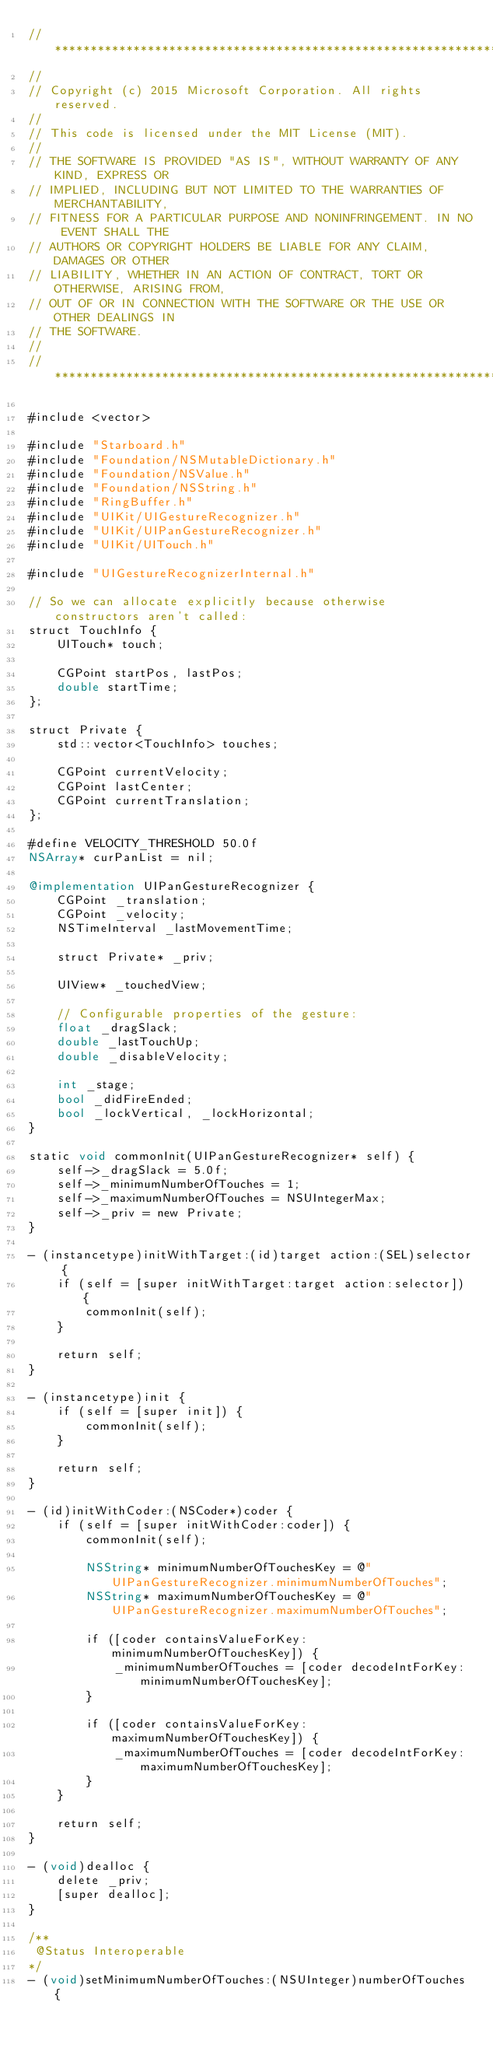Convert code to text. <code><loc_0><loc_0><loc_500><loc_500><_ObjectiveC_>//******************************************************************************
//
// Copyright (c) 2015 Microsoft Corporation. All rights reserved.
//
// This code is licensed under the MIT License (MIT).
//
// THE SOFTWARE IS PROVIDED "AS IS", WITHOUT WARRANTY OF ANY KIND, EXPRESS OR
// IMPLIED, INCLUDING BUT NOT LIMITED TO THE WARRANTIES OF MERCHANTABILITY,
// FITNESS FOR A PARTICULAR PURPOSE AND NONINFRINGEMENT. IN NO EVENT SHALL THE
// AUTHORS OR COPYRIGHT HOLDERS BE LIABLE FOR ANY CLAIM, DAMAGES OR OTHER
// LIABILITY, WHETHER IN AN ACTION OF CONTRACT, TORT OR OTHERWISE, ARISING FROM,
// OUT OF OR IN CONNECTION WITH THE SOFTWARE OR THE USE OR OTHER DEALINGS IN
// THE SOFTWARE.
//
//******************************************************************************

#include <vector>

#include "Starboard.h"
#include "Foundation/NSMutableDictionary.h"
#include "Foundation/NSValue.h"
#include "Foundation/NSString.h"
#include "RingBuffer.h"
#include "UIKit/UIGestureRecognizer.h"
#include "UIKit/UIPanGestureRecognizer.h"
#include "UIKit/UITouch.h"

#include "UIGestureRecognizerInternal.h"

// So we can allocate explicitly because otherwise constructors aren't called:
struct TouchInfo {
    UITouch* touch;

    CGPoint startPos, lastPos;
    double startTime;
};

struct Private {
    std::vector<TouchInfo> touches;

    CGPoint currentVelocity;
    CGPoint lastCenter;
    CGPoint currentTranslation;
};

#define VELOCITY_THRESHOLD 50.0f
NSArray* curPanList = nil;

@implementation UIPanGestureRecognizer {
    CGPoint _translation;
    CGPoint _velocity;
    NSTimeInterval _lastMovementTime;

    struct Private* _priv;

    UIView* _touchedView;

    // Configurable properties of the gesture:
    float _dragSlack;
    double _lastTouchUp;
    double _disableVelocity;

    int _stage;
    bool _didFireEnded;
    bool _lockVertical, _lockHorizontal;
}

static void commonInit(UIPanGestureRecognizer* self) {
    self->_dragSlack = 5.0f;
    self->_minimumNumberOfTouches = 1;
    self->_maximumNumberOfTouches = NSUIntegerMax;
    self->_priv = new Private;
}

- (instancetype)initWithTarget:(id)target action:(SEL)selector {
    if (self = [super initWithTarget:target action:selector]) {
        commonInit(self);
    }

    return self;
}

- (instancetype)init {
    if (self = [super init]) {
        commonInit(self);
    }

    return self;
}

- (id)initWithCoder:(NSCoder*)coder {
    if (self = [super initWithCoder:coder]) {
        commonInit(self);

        NSString* minimumNumberOfTouchesKey = @"UIPanGestureRecognizer.minimumNumberOfTouches";
        NSString* maximumNumberOfTouchesKey = @"UIPanGestureRecognizer.maximumNumberOfTouches";

        if ([coder containsValueForKey:minimumNumberOfTouchesKey]) {
            _minimumNumberOfTouches = [coder decodeIntForKey:minimumNumberOfTouchesKey];
        }

        if ([coder containsValueForKey:maximumNumberOfTouchesKey]) {
            _maximumNumberOfTouches = [coder decodeIntForKey:maximumNumberOfTouchesKey];
        }
    }

    return self;
}

- (void)dealloc {
    delete _priv;
    [super dealloc];
}

/**
 @Status Interoperable
*/
- (void)setMinimumNumberOfTouches:(NSUInteger)numberOfTouches {</code> 